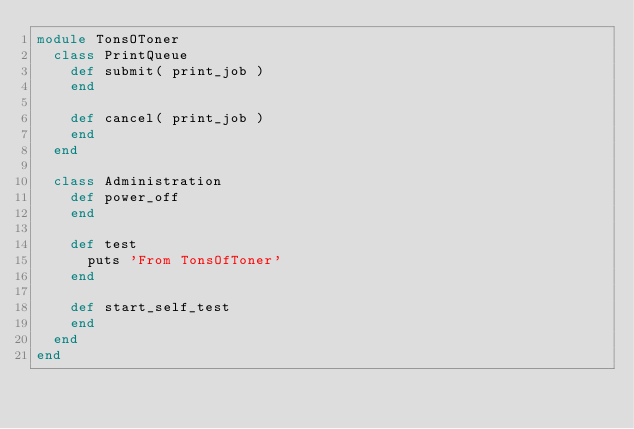<code> <loc_0><loc_0><loc_500><loc_500><_Ruby_>module TonsOToner
  class PrintQueue
    def submit( print_job )
    end

    def cancel( print_job )
    end
  end

  class Administration
    def power_off
    end
    
    def test
      puts 'From TonsOfToner'
    end

    def start_self_test
    end
  end
end
</code> 